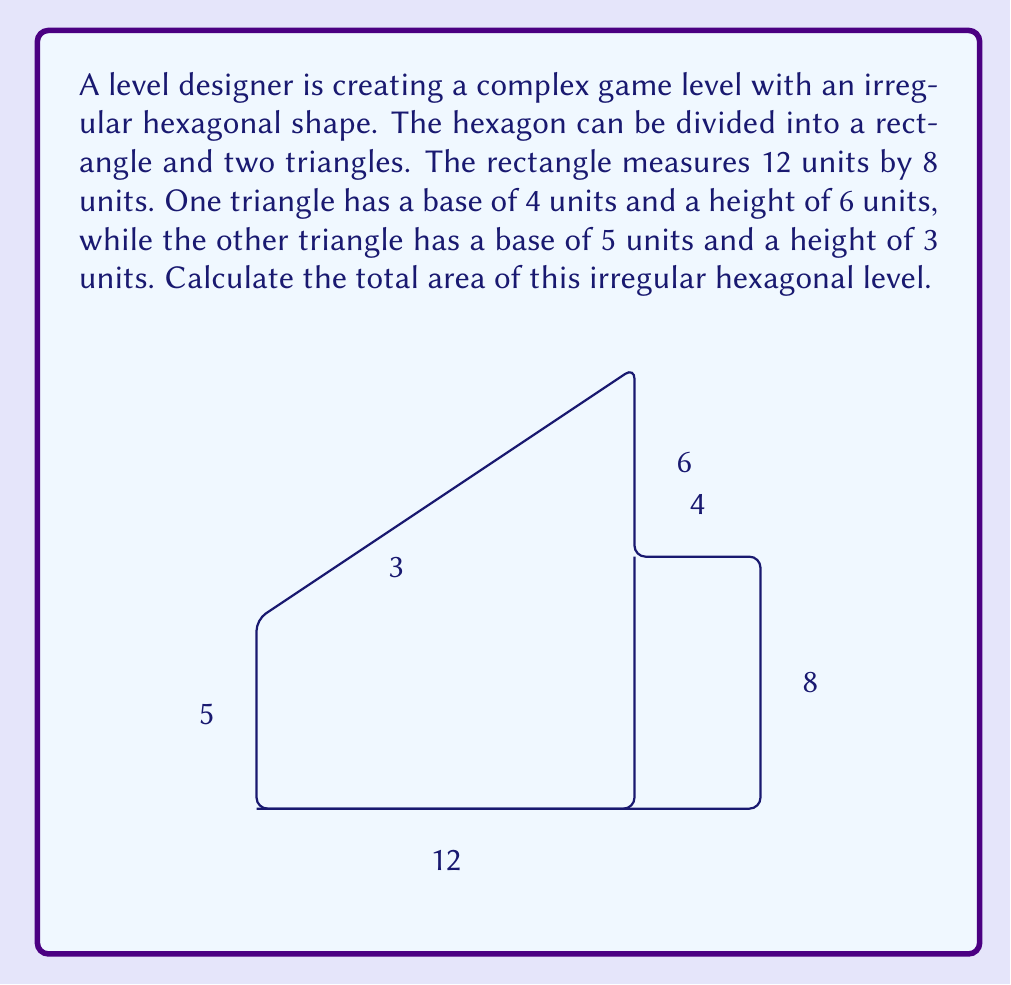What is the answer to this math problem? To find the area of this irregular hexagon, we'll calculate the areas of its components and sum them up:

1) Area of the rectangle:
   $$A_r = l \times w = 12 \times 8 = 96$$ square units

2) Area of the first triangle (right side):
   $$A_{t1} = \frac{1}{2} \times b \times h = \frac{1}{2} \times 4 \times 6 = 12$$ square units

3) Area of the second triangle (left side):
   $$A_{t2} = \frac{1}{2} \times b \times h = \frac{1}{2} \times 5 \times 3 = 7.5$$ square units

4) Total area of the irregular hexagon:
   $$A_{total} = A_r + A_{t1} + A_{t2} = 96 + 12 + 7.5 = 115.5$$ square units

Therefore, the total area of the irregular hexagonal level is 115.5 square units.
Answer: 115.5 square units 